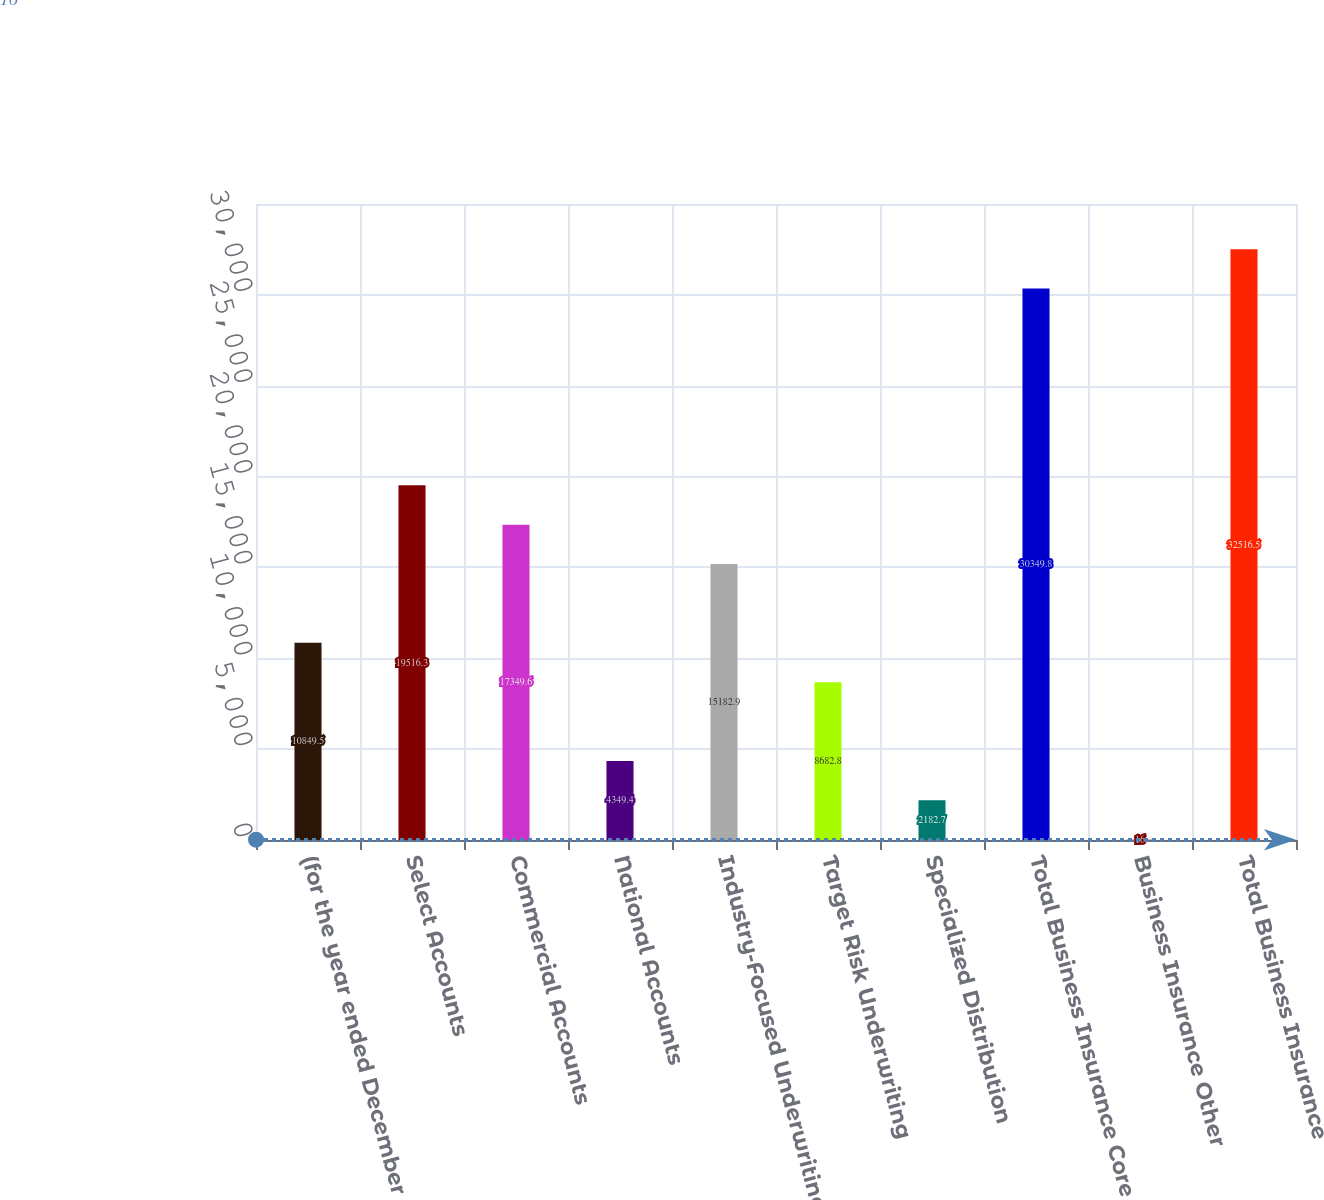<chart> <loc_0><loc_0><loc_500><loc_500><bar_chart><fcel>(for the year ended December<fcel>Select Accounts<fcel>Commercial Accounts<fcel>National Accounts<fcel>Industry-Focused Underwriting<fcel>Target Risk Underwriting<fcel>Specialized Distribution<fcel>Total Business Insurance Core<fcel>Business Insurance Other<fcel>Total Business Insurance<nl><fcel>10849.5<fcel>19516.3<fcel>17349.6<fcel>4349.4<fcel>15182.9<fcel>8682.8<fcel>2182.7<fcel>30349.8<fcel>16<fcel>32516.5<nl></chart> 